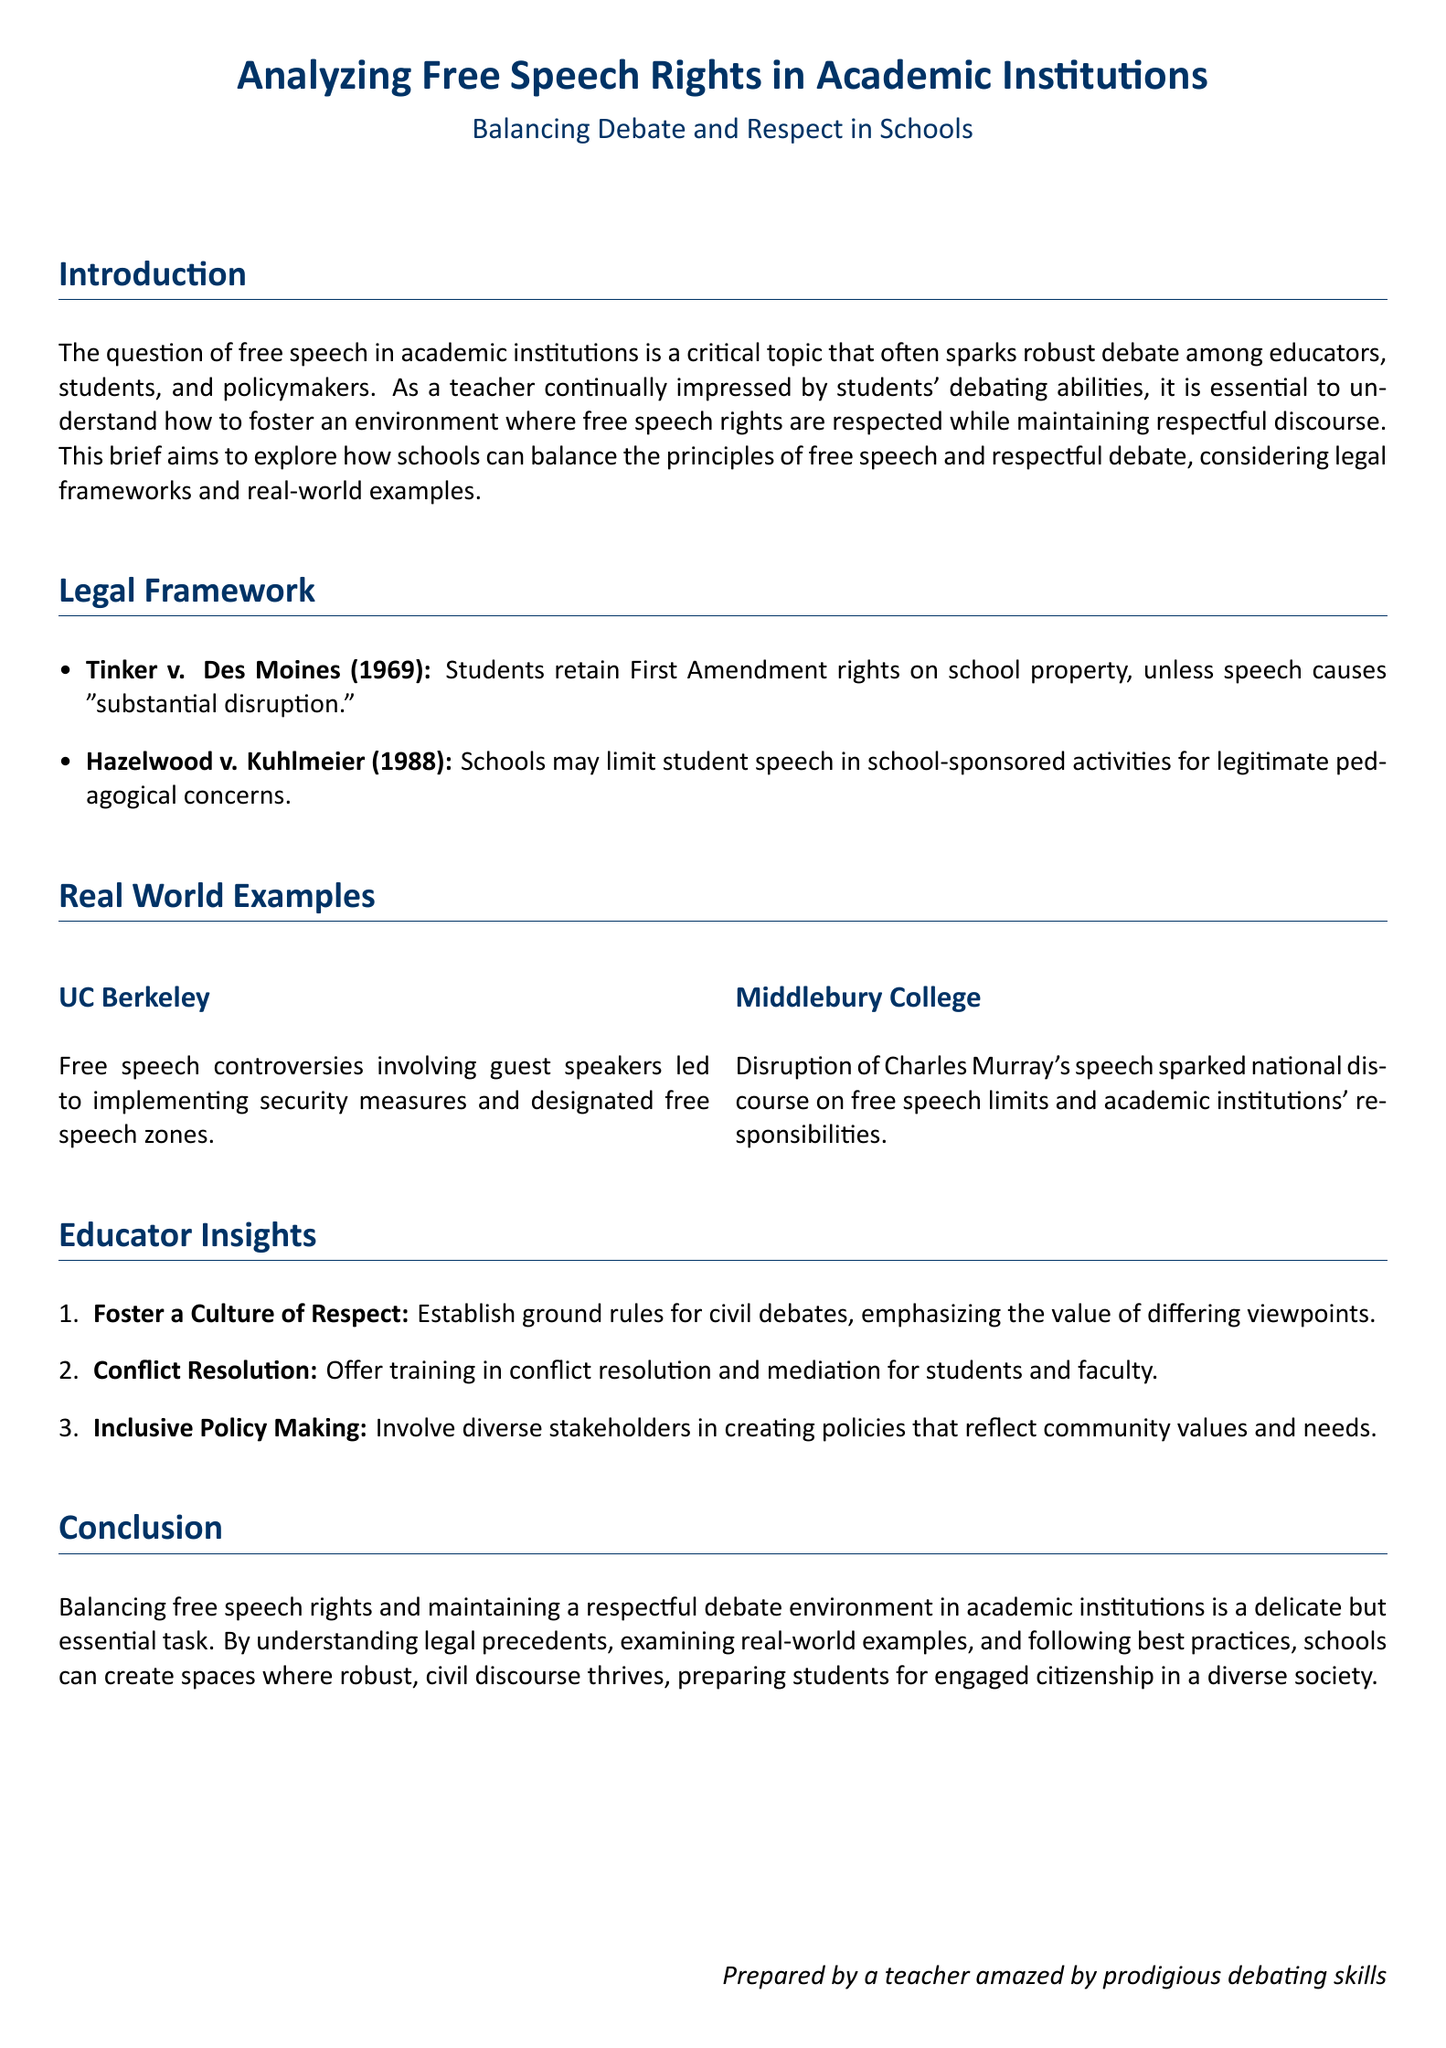What is the title of the document? The title of the document is mentioned prominently at the beginning, highlighting the main focus of the legal brief.
Answer: Analyzing Free Speech Rights in Academic Institutions What year was Tinker v. Des Moines decided? The year in which the Tinker v. Des Moines case was decided is provided in the legal framework section.
Answer: 1969 What are the two main legal cases discussed in the legal framework? The legal framework section lists two significant cases that inform free speech rights in schools.
Answer: Tinker v. Des Moines and Hazelwood v. Kuhlmeier What does the acronym UC stand for in the example given? The examples in the document use the abbreviation UC before Berkeley to refer to the university, which is common knowledge.
Answer: University of California What is one way educators can foster a culture of respect? The document provides insights from educators on how to maintain respectful discourse and offers specific strategies.
Answer: Establish ground rules for civil debates Which college had a notable disruption involving Charles Murray? The real-world examples section mentions a specific incident at a college regarding a speaker.
Answer: Middlebury College What is a suggested strategy for conflict resolution? The document outlines valuable practices for educators, including training that can help in resolving disagreements.
Answer: Offer training in conflict resolution and mediation What is the primary goal of the document? The purpose of the brief is stated in the introduction, summarizing its intent to address a significant issue in education.
Answer: Balancing free speech rights and respectful debate Who prepared this legal brief? The authorship of the document is revealed at the bottom, attributing it to a specific persona.
Answer: A teacher amazed by prodigious debating skills 